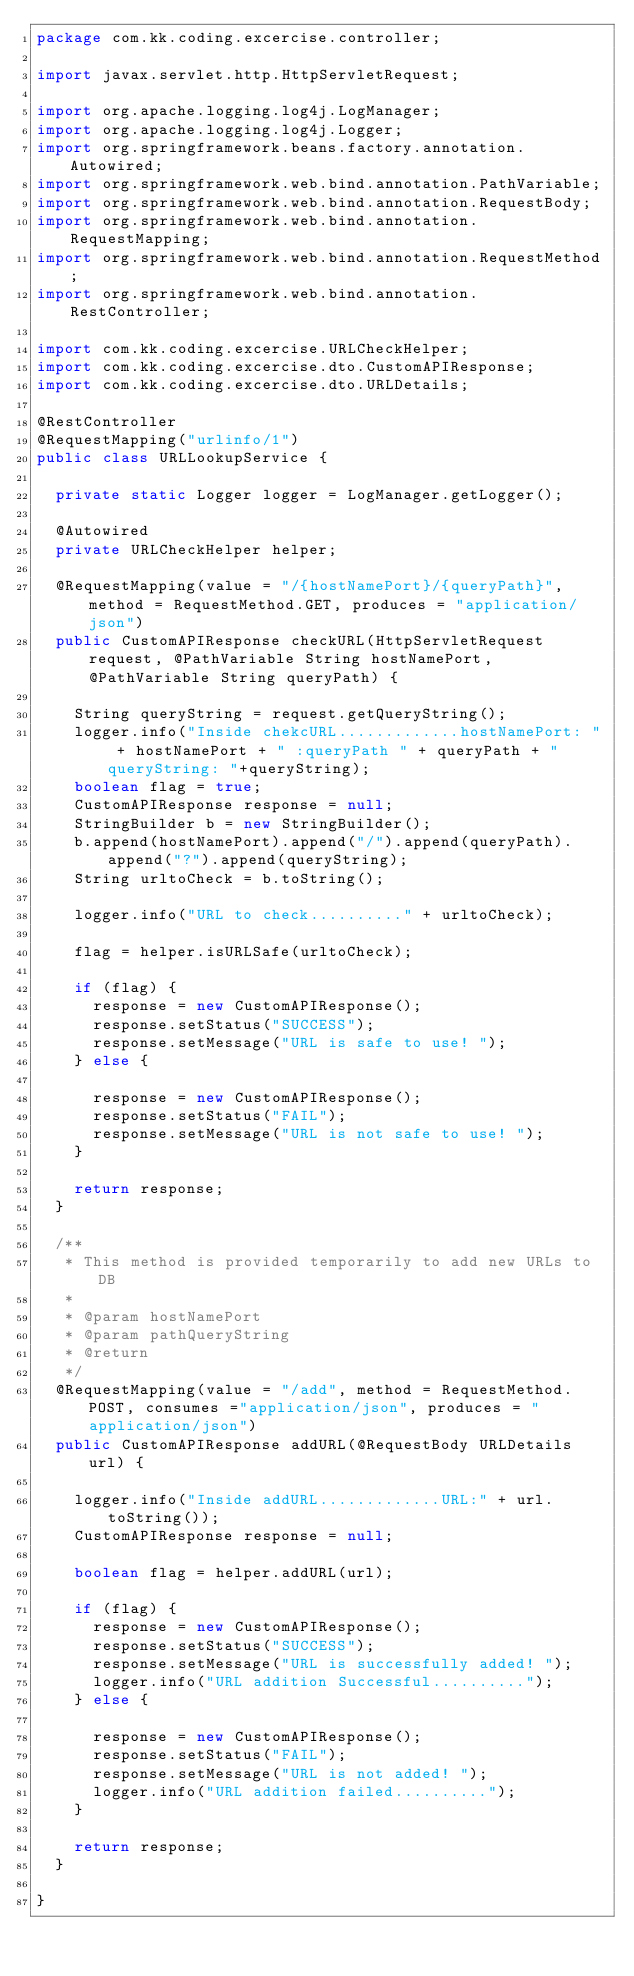Convert code to text. <code><loc_0><loc_0><loc_500><loc_500><_Java_>package com.kk.coding.excercise.controller;

import javax.servlet.http.HttpServletRequest;

import org.apache.logging.log4j.LogManager;
import org.apache.logging.log4j.Logger;
import org.springframework.beans.factory.annotation.Autowired;
import org.springframework.web.bind.annotation.PathVariable;
import org.springframework.web.bind.annotation.RequestBody;
import org.springframework.web.bind.annotation.RequestMapping;
import org.springframework.web.bind.annotation.RequestMethod;
import org.springframework.web.bind.annotation.RestController;

import com.kk.coding.excercise.URLCheckHelper;
import com.kk.coding.excercise.dto.CustomAPIResponse;
import com.kk.coding.excercise.dto.URLDetails;

@RestController
@RequestMapping("urlinfo/1")
public class URLLookupService {

	private static Logger logger = LogManager.getLogger();

	@Autowired
	private URLCheckHelper helper;

	@RequestMapping(value = "/{hostNamePort}/{queryPath}", method = RequestMethod.GET, produces = "application/json")
	public CustomAPIResponse checkURL(HttpServletRequest request, @PathVariable String hostNamePort, @PathVariable String queryPath) {
		
		String queryString = request.getQueryString();
		logger.info("Inside chekcURL.............hostNamePort: " + hostNamePort + " :queryPath " + queryPath + " queryString: "+queryString);
		boolean flag = true;
		CustomAPIResponse response = null;
		StringBuilder b = new StringBuilder();
		b.append(hostNamePort).append("/").append(queryPath).append("?").append(queryString);
		String urltoCheck = b.toString();

		logger.info("URL to check.........." + urltoCheck);

		flag = helper.isURLSafe(urltoCheck);

		if (flag) {
			response = new CustomAPIResponse();
			response.setStatus("SUCCESS");
			response.setMessage("URL is safe to use! ");
		} else {

			response = new CustomAPIResponse();
			response.setStatus("FAIL");
			response.setMessage("URL is not safe to use! ");
		}

		return response;
	}

	/**
	 * This method is provided temporarily to add new URLs to DB
	 * 
	 * @param hostNamePort
	 * @param pathQueryString
	 * @return
	 */
	@RequestMapping(value = "/add", method = RequestMethod.POST, consumes ="application/json", produces = "application/json")
	public CustomAPIResponse addURL(@RequestBody URLDetails url) {

		logger.info("Inside addURL.............URL:" + url.toString());
		CustomAPIResponse response = null;
	
		boolean flag = helper.addURL(url);
		
		if (flag) {
			response = new CustomAPIResponse();
			response.setStatus("SUCCESS");
			response.setMessage("URL is successfully added! ");
			logger.info("URL addition Successful..........");
		} else {

			response = new CustomAPIResponse();
			response.setStatus("FAIL");
			response.setMessage("URL is not added! ");
			logger.info("URL addition failed..........");
		}

		return response;
	}

}
</code> 